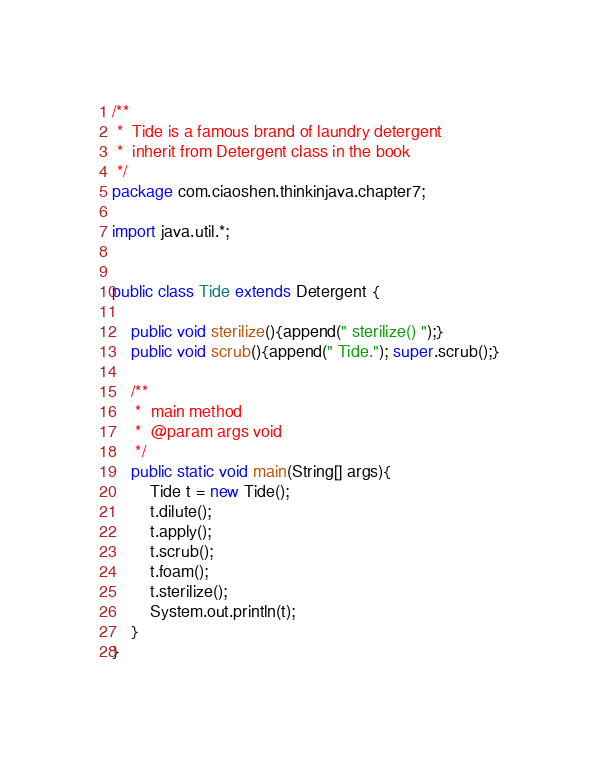Convert code to text. <code><loc_0><loc_0><loc_500><loc_500><_Java_>/**
 *  Tide is a famous brand of laundry detergent
 *  inherit from Detergent class in the book
 */
package com.ciaoshen.thinkinjava.chapter7;

import java.util.*;


public class Tide extends Detergent {

    public void sterilize(){append(" sterilize() ");}
    public void scrub(){append(" Tide."); super.scrub();}

    /**
     *  main method
     *  @param args void
     */
    public static void main(String[] args){
        Tide t = new Tide();
        t.dilute();
        t.apply();
        t.scrub();
        t.foam();
        t.sterilize();
        System.out.println(t);
    }
}</code> 